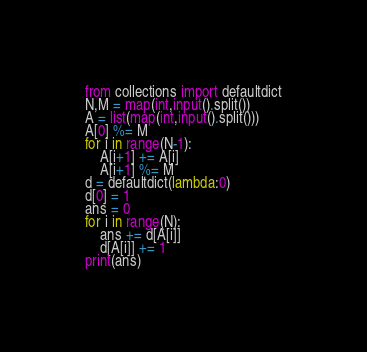Convert code to text. <code><loc_0><loc_0><loc_500><loc_500><_Python_>from collections import defaultdict
N,M = map(int,input().split())
A = list(map(int,input().split()))
A[0] %= M
for i in range(N-1):
    A[i+1] += A[i]
    A[i+1] %= M
d = defaultdict(lambda:0)
d[0] = 1
ans = 0
for i in range(N):
    ans += d[A[i]]
    d[A[i]] += 1
print(ans)</code> 